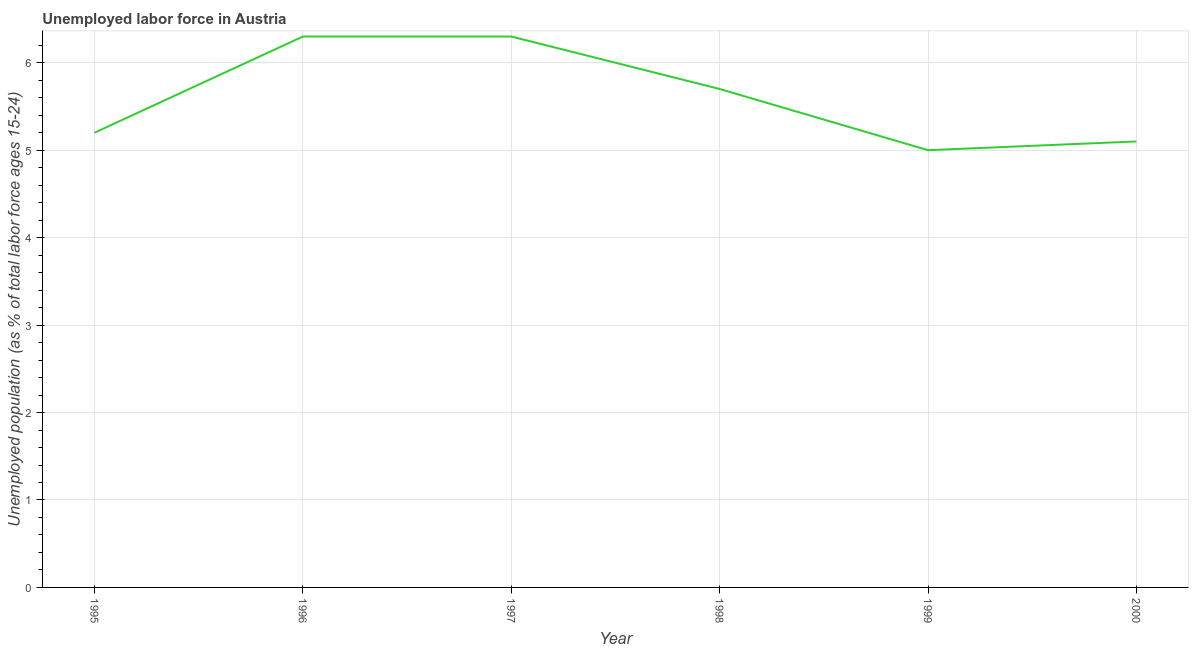What is the total unemployed youth population in 1997?
Give a very brief answer. 6.3. Across all years, what is the maximum total unemployed youth population?
Keep it short and to the point. 6.3. In which year was the total unemployed youth population maximum?
Provide a short and direct response. 1996. In which year was the total unemployed youth population minimum?
Keep it short and to the point. 1999. What is the sum of the total unemployed youth population?
Your answer should be very brief. 33.6. What is the difference between the total unemployed youth population in 1995 and 1997?
Give a very brief answer. -1.1. What is the average total unemployed youth population per year?
Keep it short and to the point. 5.6. What is the median total unemployed youth population?
Your response must be concise. 5.45. What is the ratio of the total unemployed youth population in 1997 to that in 2000?
Your answer should be compact. 1.24. Is the difference between the total unemployed youth population in 1996 and 2000 greater than the difference between any two years?
Keep it short and to the point. No. What is the difference between the highest and the second highest total unemployed youth population?
Offer a terse response. 0. What is the difference between the highest and the lowest total unemployed youth population?
Keep it short and to the point. 1.3. How many years are there in the graph?
Provide a succinct answer. 6. Does the graph contain grids?
Your response must be concise. Yes. What is the title of the graph?
Your response must be concise. Unemployed labor force in Austria. What is the label or title of the Y-axis?
Keep it short and to the point. Unemployed population (as % of total labor force ages 15-24). What is the Unemployed population (as % of total labor force ages 15-24) of 1995?
Keep it short and to the point. 5.2. What is the Unemployed population (as % of total labor force ages 15-24) of 1996?
Your answer should be very brief. 6.3. What is the Unemployed population (as % of total labor force ages 15-24) in 1997?
Offer a very short reply. 6.3. What is the Unemployed population (as % of total labor force ages 15-24) in 1998?
Ensure brevity in your answer.  5.7. What is the Unemployed population (as % of total labor force ages 15-24) in 2000?
Offer a terse response. 5.1. What is the difference between the Unemployed population (as % of total labor force ages 15-24) in 1995 and 1997?
Give a very brief answer. -1.1. What is the difference between the Unemployed population (as % of total labor force ages 15-24) in 1995 and 1999?
Your response must be concise. 0.2. What is the difference between the Unemployed population (as % of total labor force ages 15-24) in 1995 and 2000?
Your answer should be compact. 0.1. What is the difference between the Unemployed population (as % of total labor force ages 15-24) in 1996 and 2000?
Give a very brief answer. 1.2. What is the difference between the Unemployed population (as % of total labor force ages 15-24) in 1997 and 1999?
Your answer should be very brief. 1.3. What is the difference between the Unemployed population (as % of total labor force ages 15-24) in 1997 and 2000?
Your answer should be compact. 1.2. What is the difference between the Unemployed population (as % of total labor force ages 15-24) in 1998 and 1999?
Offer a terse response. 0.7. What is the difference between the Unemployed population (as % of total labor force ages 15-24) in 1998 and 2000?
Your answer should be very brief. 0.6. What is the ratio of the Unemployed population (as % of total labor force ages 15-24) in 1995 to that in 1996?
Your answer should be compact. 0.82. What is the ratio of the Unemployed population (as % of total labor force ages 15-24) in 1995 to that in 1997?
Provide a succinct answer. 0.82. What is the ratio of the Unemployed population (as % of total labor force ages 15-24) in 1995 to that in 1998?
Provide a succinct answer. 0.91. What is the ratio of the Unemployed population (as % of total labor force ages 15-24) in 1995 to that in 2000?
Provide a short and direct response. 1.02. What is the ratio of the Unemployed population (as % of total labor force ages 15-24) in 1996 to that in 1998?
Keep it short and to the point. 1.1. What is the ratio of the Unemployed population (as % of total labor force ages 15-24) in 1996 to that in 1999?
Provide a succinct answer. 1.26. What is the ratio of the Unemployed population (as % of total labor force ages 15-24) in 1996 to that in 2000?
Give a very brief answer. 1.24. What is the ratio of the Unemployed population (as % of total labor force ages 15-24) in 1997 to that in 1998?
Provide a short and direct response. 1.1. What is the ratio of the Unemployed population (as % of total labor force ages 15-24) in 1997 to that in 1999?
Ensure brevity in your answer.  1.26. What is the ratio of the Unemployed population (as % of total labor force ages 15-24) in 1997 to that in 2000?
Make the answer very short. 1.24. What is the ratio of the Unemployed population (as % of total labor force ages 15-24) in 1998 to that in 1999?
Keep it short and to the point. 1.14. What is the ratio of the Unemployed population (as % of total labor force ages 15-24) in 1998 to that in 2000?
Offer a very short reply. 1.12. What is the ratio of the Unemployed population (as % of total labor force ages 15-24) in 1999 to that in 2000?
Make the answer very short. 0.98. 